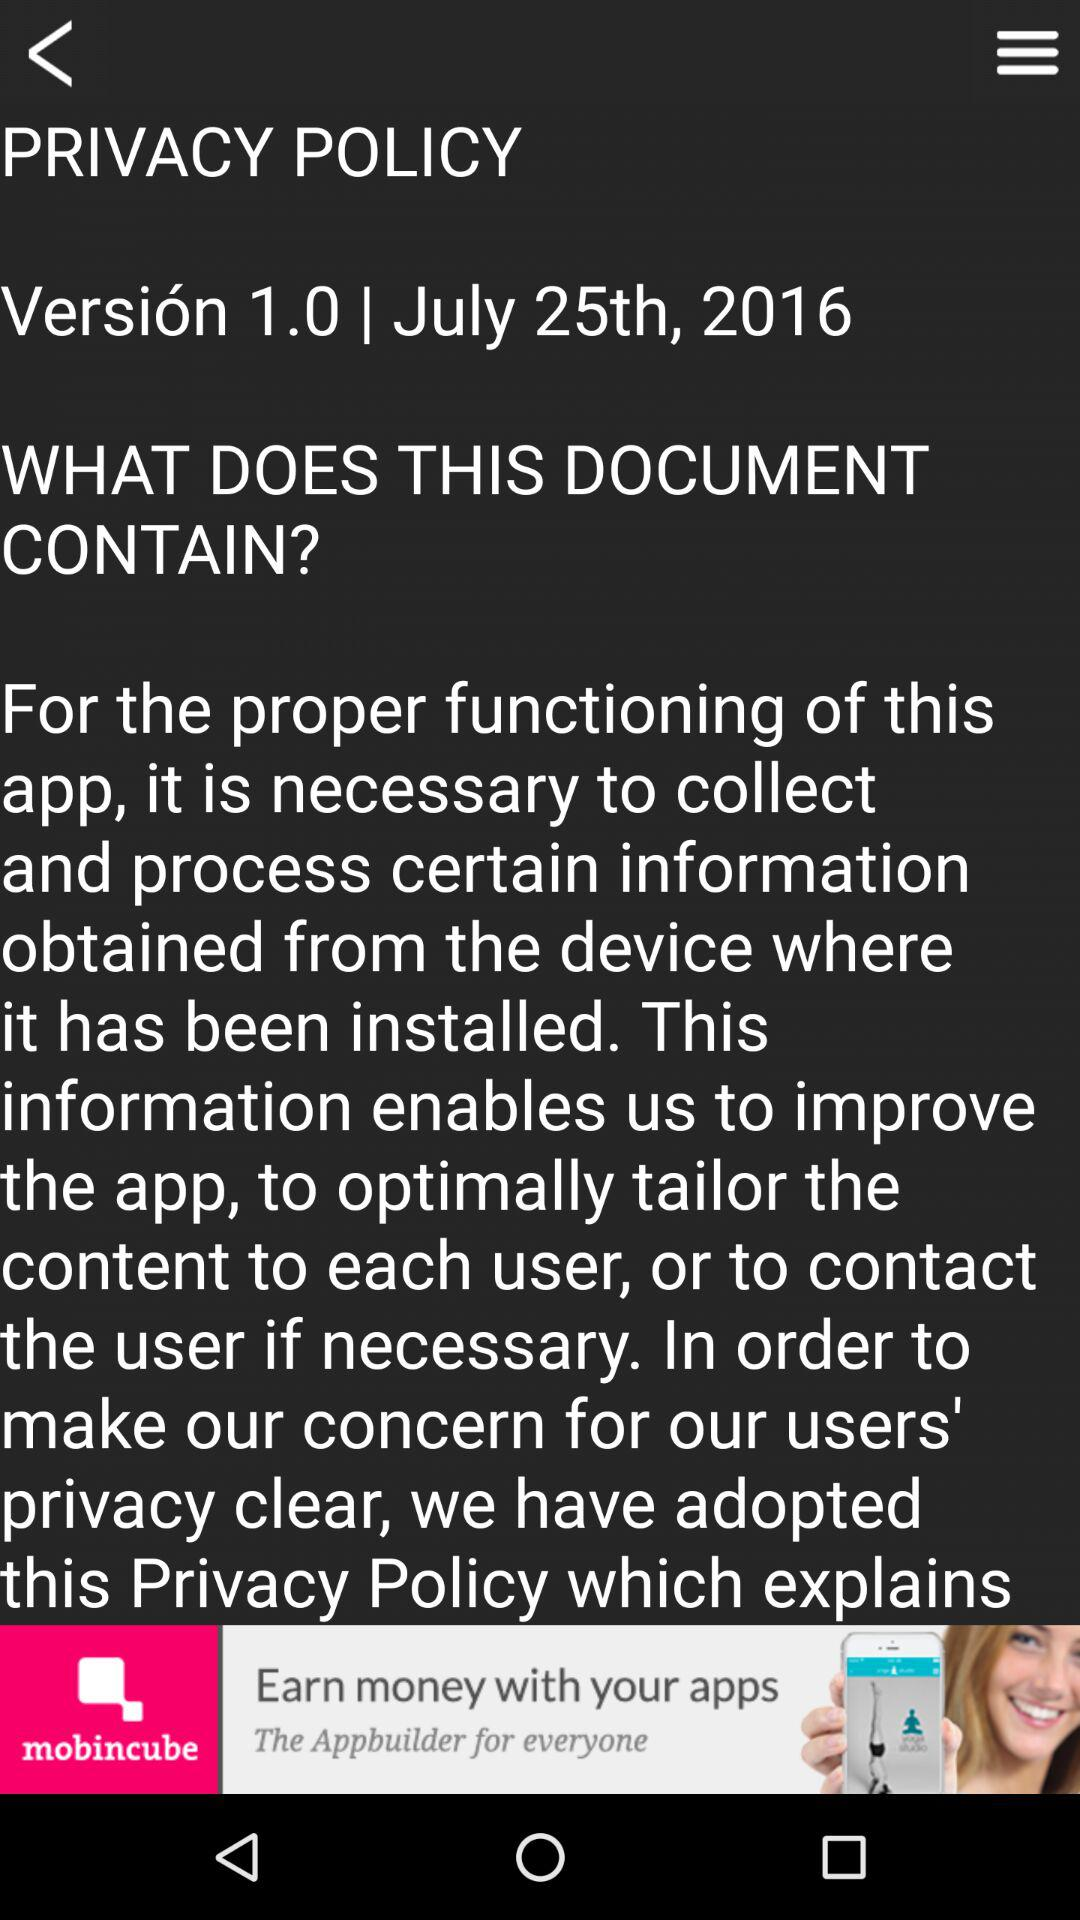What is the version number? The version number is 1.0. 